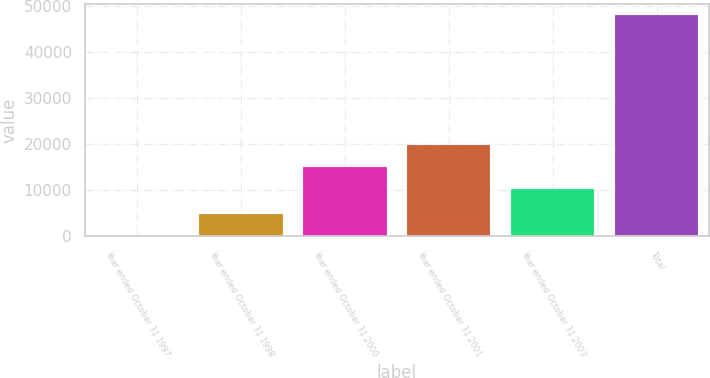Convert chart. <chart><loc_0><loc_0><loc_500><loc_500><bar_chart><fcel>Year ended October 31 1997<fcel>Year ended October 31 1998<fcel>Year ended October 31 2000<fcel>Year ended October 31 2001<fcel>Year ended October 31 2003<fcel>Total<nl><fcel>76<fcel>4878.5<fcel>15061.5<fcel>19864<fcel>10259<fcel>48101<nl></chart> 